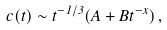Convert formula to latex. <formula><loc_0><loc_0><loc_500><loc_500>c ( t ) \sim t ^ { - 1 / 3 } ( A + B t ^ { - x } ) \, ,</formula> 